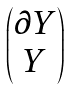Convert formula to latex. <formula><loc_0><loc_0><loc_500><loc_500>\begin{pmatrix} \partial Y \\ Y \end{pmatrix}</formula> 